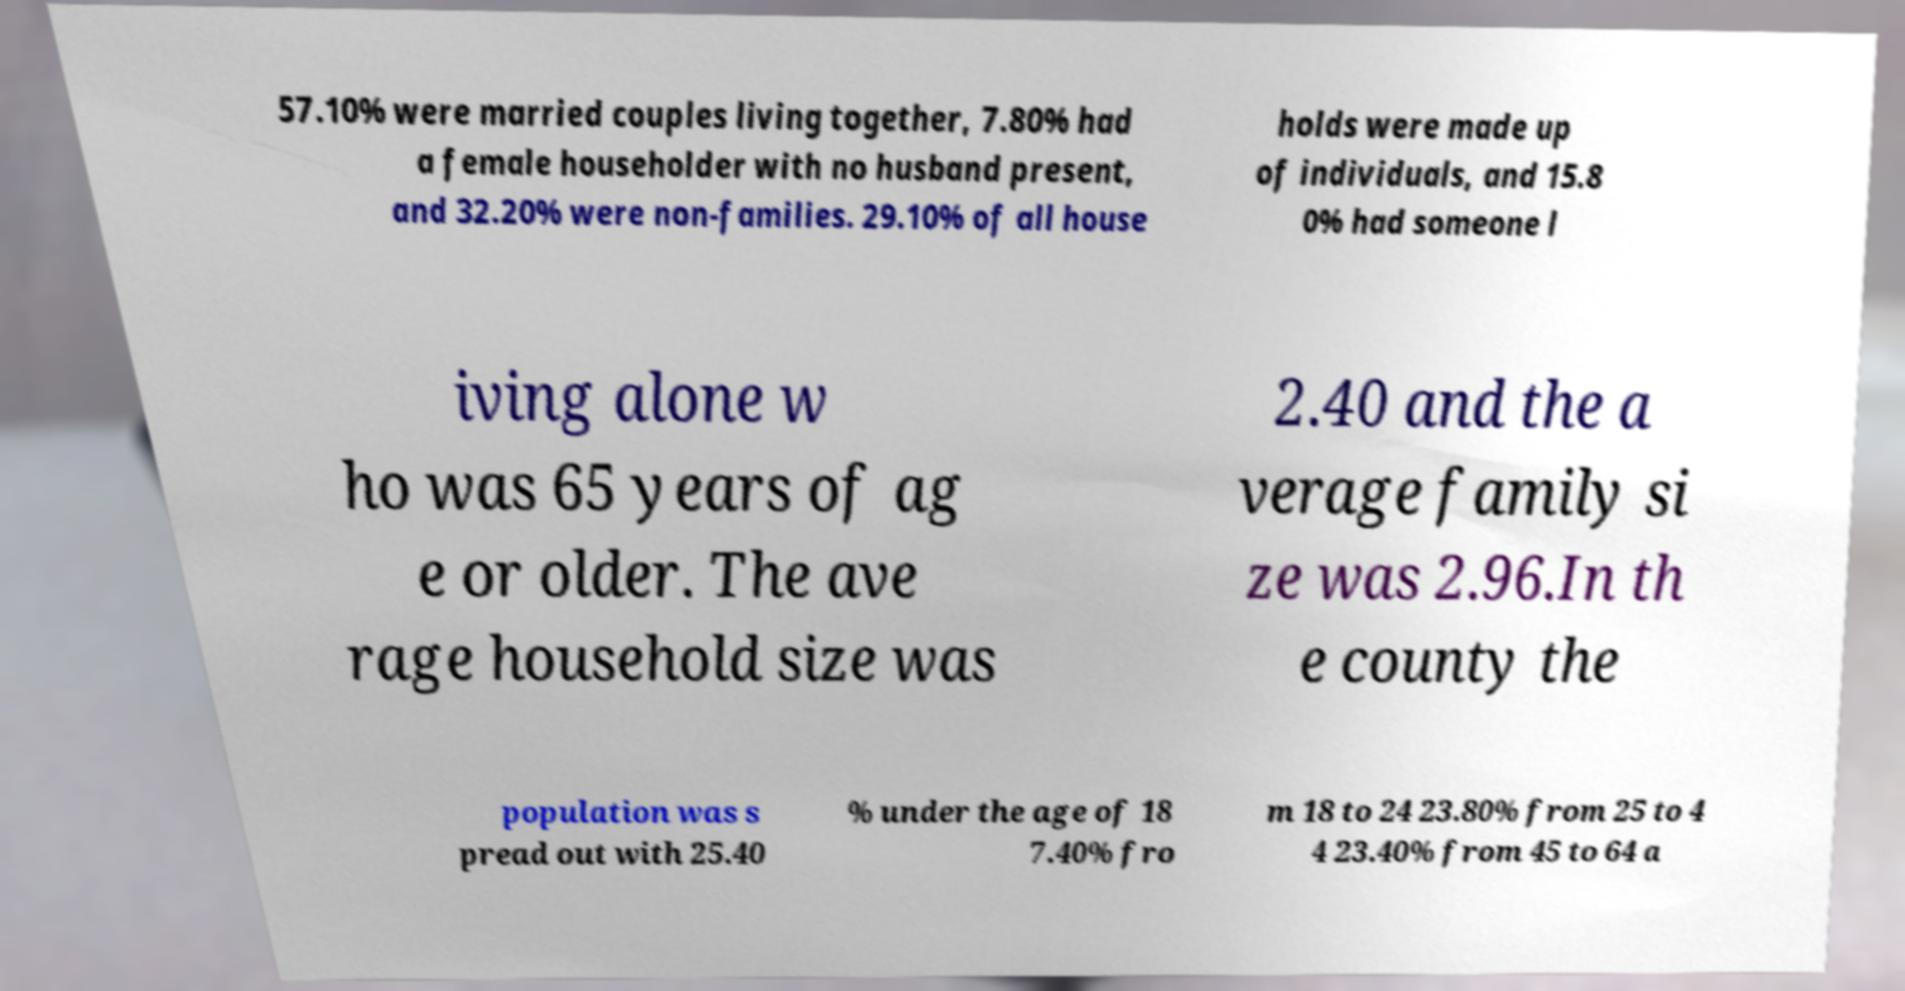Can you read and provide the text displayed in the image?This photo seems to have some interesting text. Can you extract and type it out for me? 57.10% were married couples living together, 7.80% had a female householder with no husband present, and 32.20% were non-families. 29.10% of all house holds were made up of individuals, and 15.8 0% had someone l iving alone w ho was 65 years of ag e or older. The ave rage household size was 2.40 and the a verage family si ze was 2.96.In th e county the population was s pread out with 25.40 % under the age of 18 7.40% fro m 18 to 24 23.80% from 25 to 4 4 23.40% from 45 to 64 a 